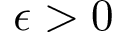Convert formula to latex. <formula><loc_0><loc_0><loc_500><loc_500>\epsilon > 0</formula> 